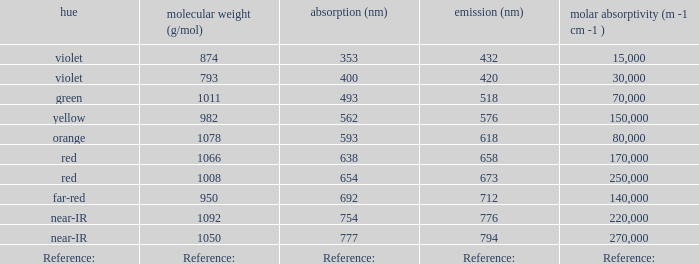Which Emission (in nanometers) has an absorbtion of 593 nm? 618.0. 